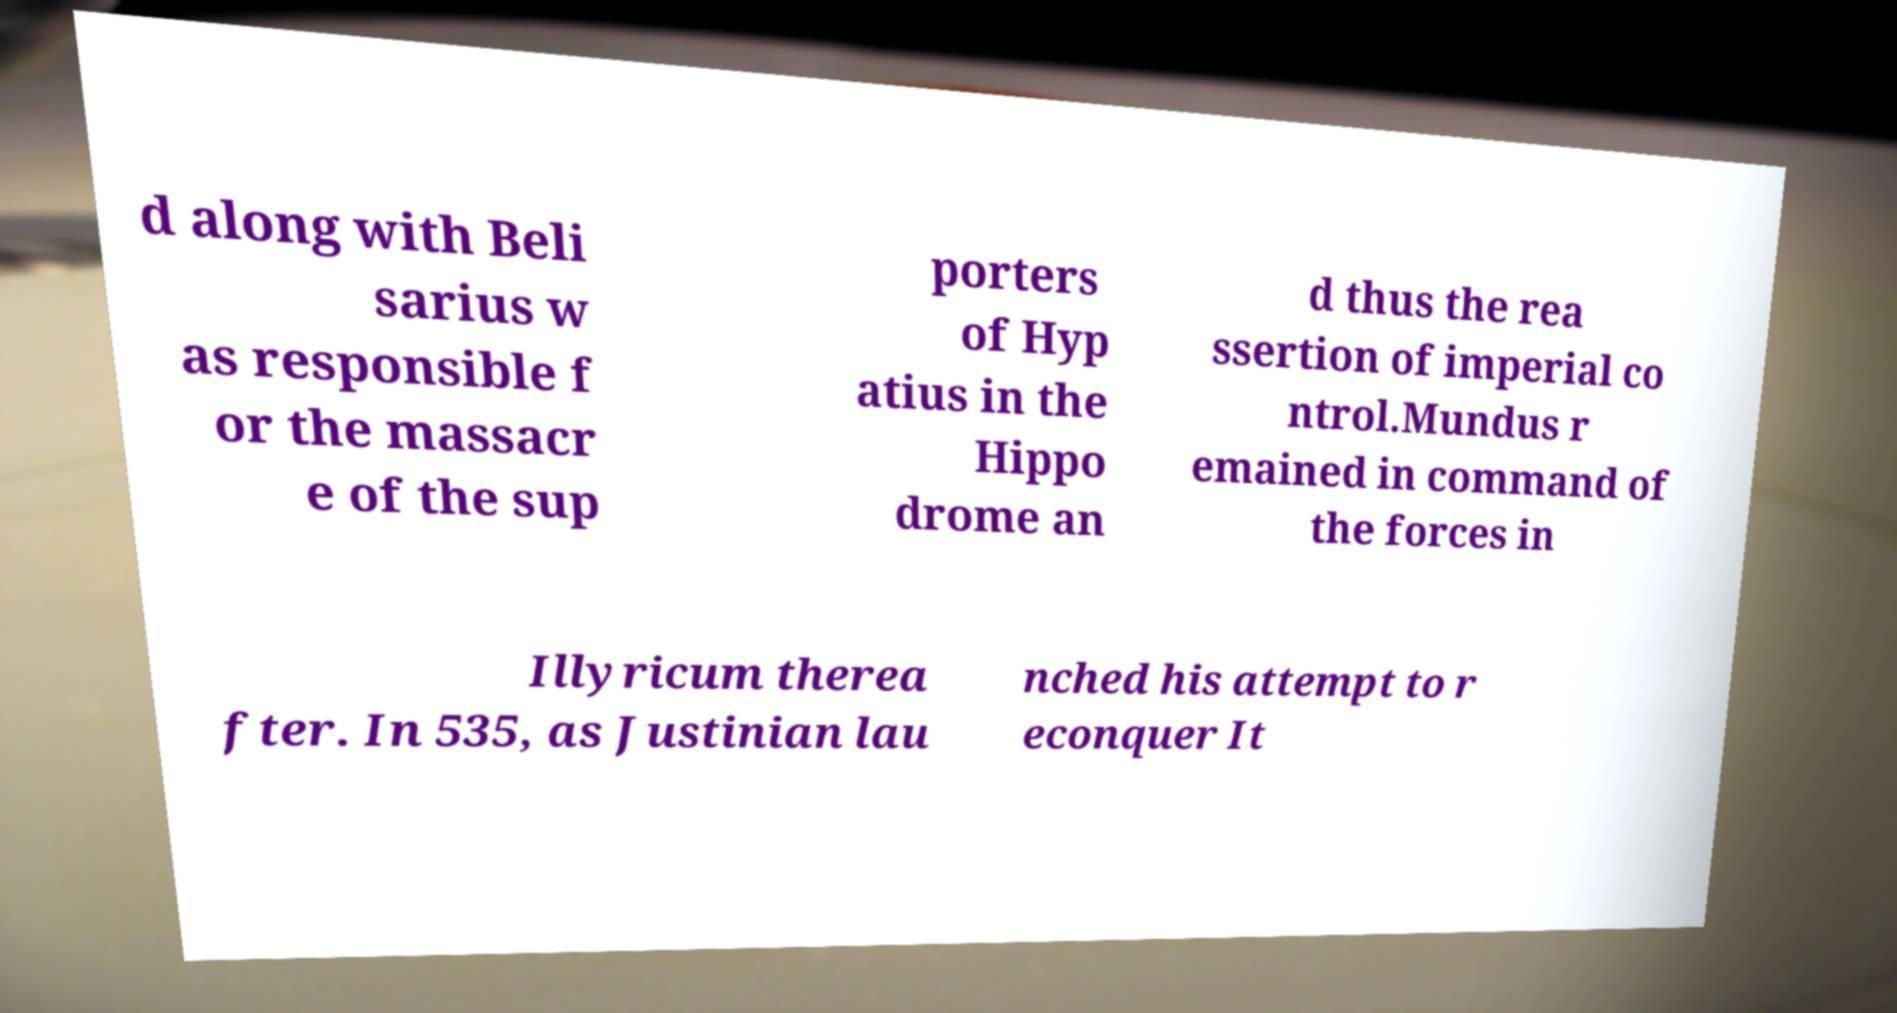Can you read and provide the text displayed in the image?This photo seems to have some interesting text. Can you extract and type it out for me? d along with Beli sarius w as responsible f or the massacr e of the sup porters of Hyp atius in the Hippo drome an d thus the rea ssertion of imperial co ntrol.Mundus r emained in command of the forces in Illyricum therea fter. In 535, as Justinian lau nched his attempt to r econquer It 